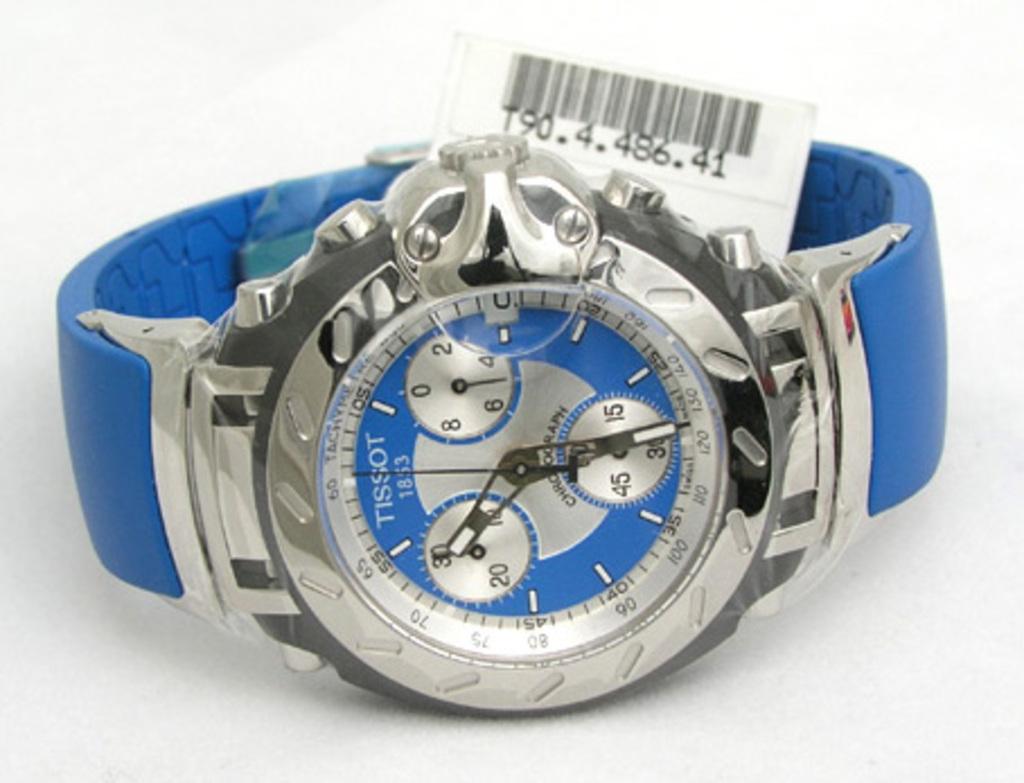What time does the watch read?
Keep it short and to the point. 10:30. Time is 10:30?
Make the answer very short. Yes. 